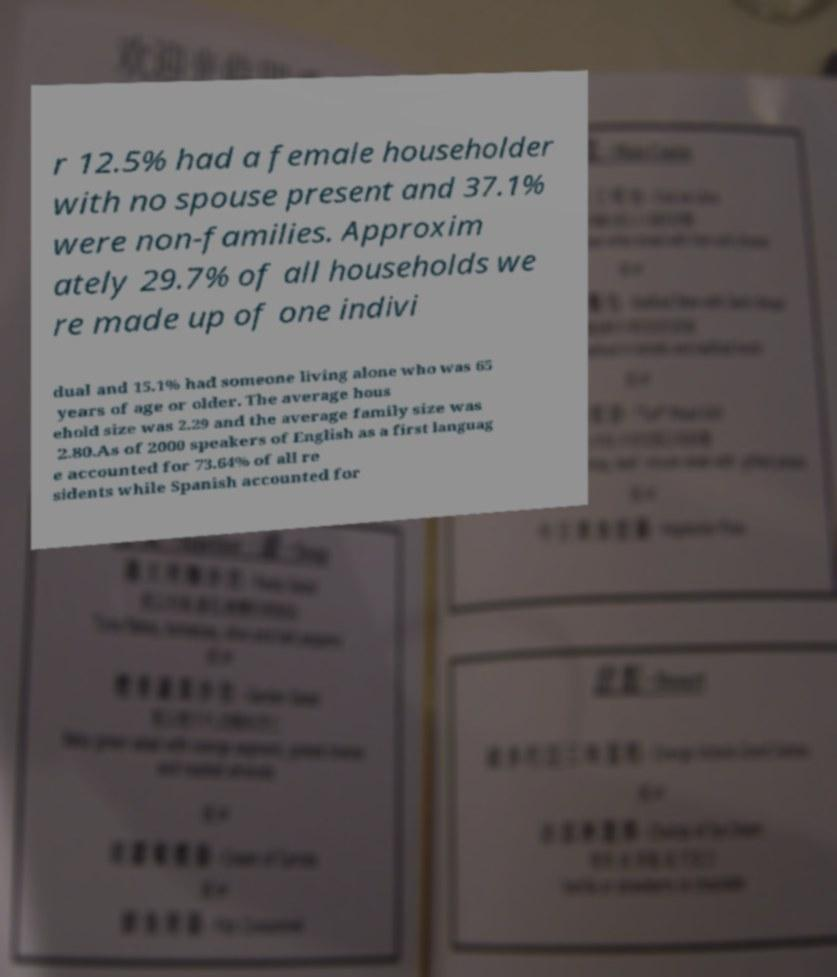Can you read and provide the text displayed in the image?This photo seems to have some interesting text. Can you extract and type it out for me? r 12.5% had a female householder with no spouse present and 37.1% were non-families. Approxim ately 29.7% of all households we re made up of one indivi dual and 15.1% had someone living alone who was 65 years of age or older. The average hous ehold size was 2.29 and the average family size was 2.80.As of 2000 speakers of English as a first languag e accounted for 73.64% of all re sidents while Spanish accounted for 